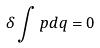Convert formula to latex. <formula><loc_0><loc_0><loc_500><loc_500>\delta \int p d q = 0</formula> 